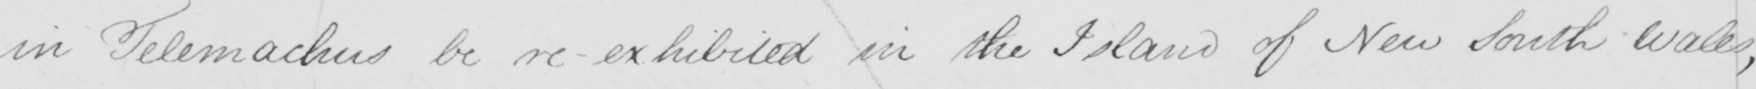Can you tell me what this handwritten text says? in Telemachus be re-exhibited in the Island of New South Wales , 